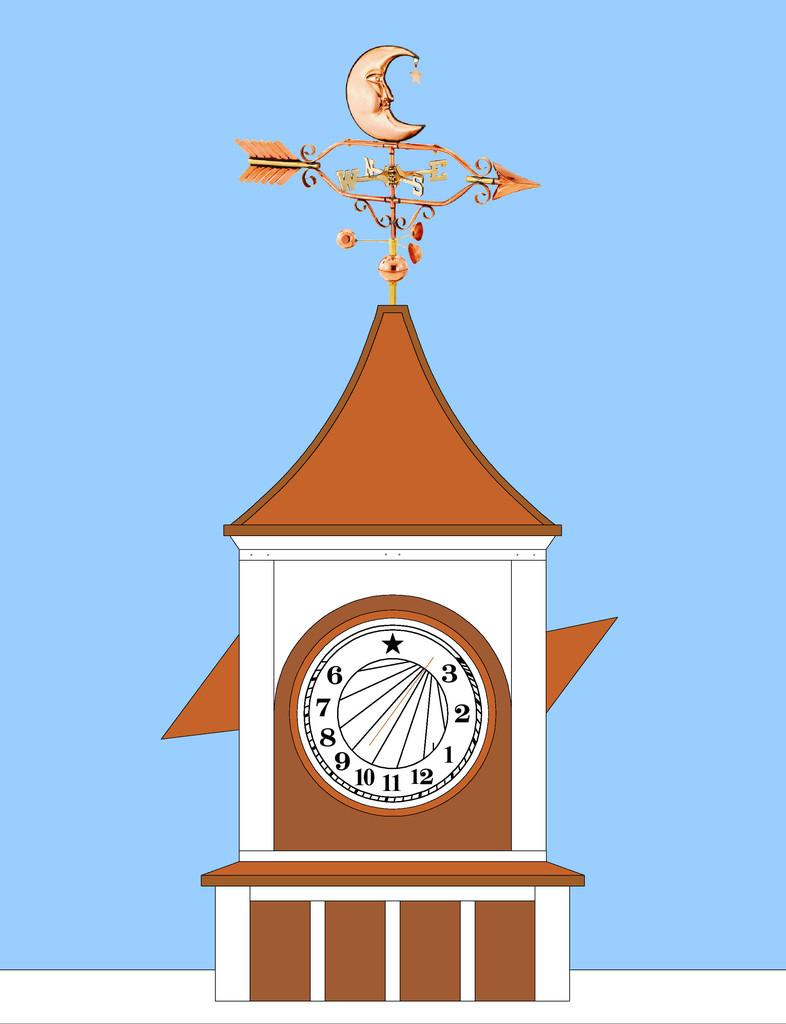Provide a one-sentence caption for the provided image. an area that has the letters 6 and 3 on it. 